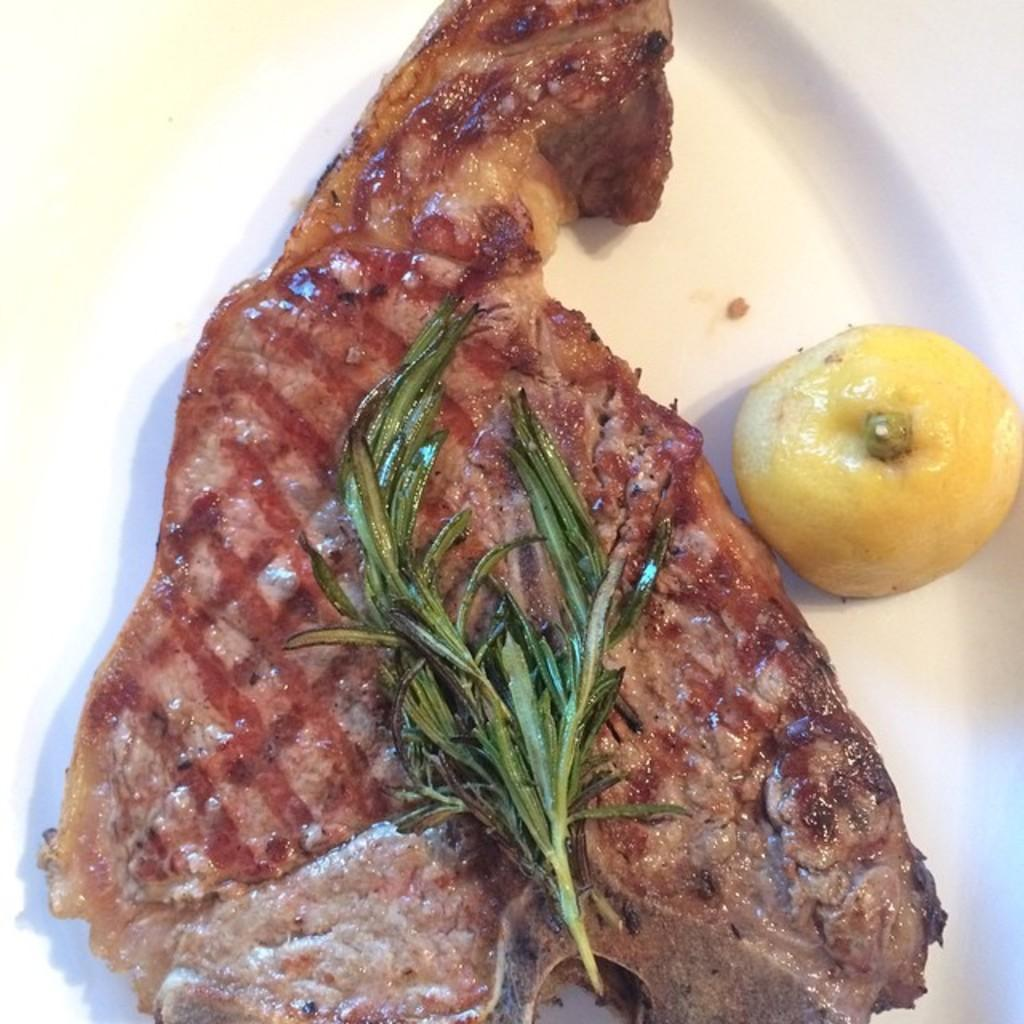What is the primary color of the surface in the image? The surface in the image is white. What type of food is on the white surface? There is a piece of meat on the white surface. What type of plant material is on the white surface? There are leaves on the white surface. What type of citrus fruit is on the white surface? There is a lemon on the white surface. What type of net is being used to catch the writer in the image? There is no net or writer present in the image. 